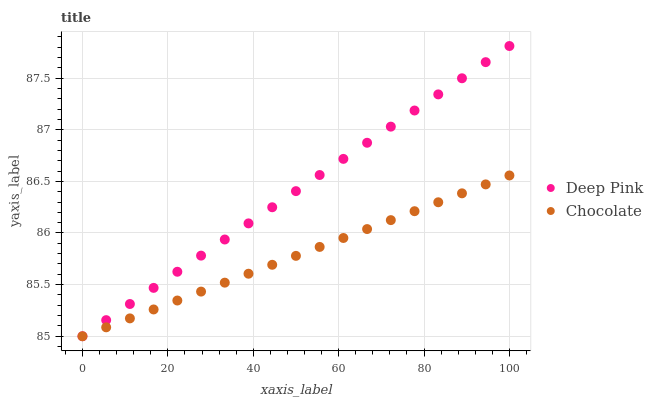Does Chocolate have the minimum area under the curve?
Answer yes or no. Yes. Does Deep Pink have the maximum area under the curve?
Answer yes or no. Yes. Does Chocolate have the maximum area under the curve?
Answer yes or no. No. Is Chocolate the smoothest?
Answer yes or no. Yes. Is Deep Pink the roughest?
Answer yes or no. Yes. Is Chocolate the roughest?
Answer yes or no. No. Does Deep Pink have the lowest value?
Answer yes or no. Yes. Does Deep Pink have the highest value?
Answer yes or no. Yes. Does Chocolate have the highest value?
Answer yes or no. No. Does Chocolate intersect Deep Pink?
Answer yes or no. Yes. Is Chocolate less than Deep Pink?
Answer yes or no. No. Is Chocolate greater than Deep Pink?
Answer yes or no. No. 